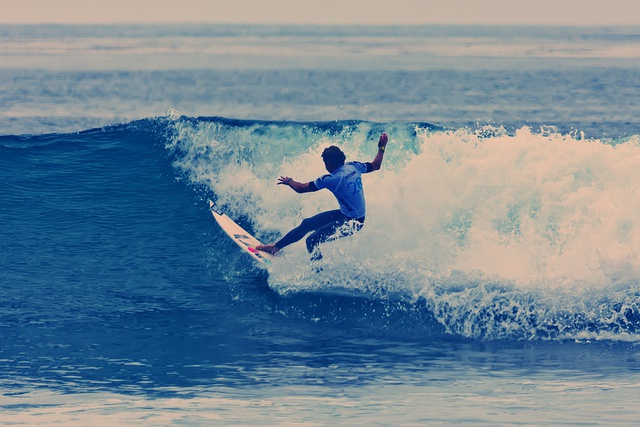Describe the objects in this image and their specific colors. I can see people in tan, navy, blue, darkblue, and darkgray tones and surfboard in tan, darkgray, and gray tones in this image. 